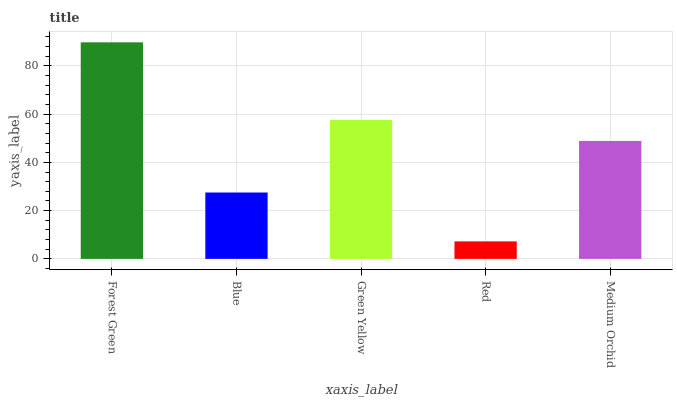Is Red the minimum?
Answer yes or no. Yes. Is Forest Green the maximum?
Answer yes or no. Yes. Is Blue the minimum?
Answer yes or no. No. Is Blue the maximum?
Answer yes or no. No. Is Forest Green greater than Blue?
Answer yes or no. Yes. Is Blue less than Forest Green?
Answer yes or no. Yes. Is Blue greater than Forest Green?
Answer yes or no. No. Is Forest Green less than Blue?
Answer yes or no. No. Is Medium Orchid the high median?
Answer yes or no. Yes. Is Medium Orchid the low median?
Answer yes or no. Yes. Is Green Yellow the high median?
Answer yes or no. No. Is Blue the low median?
Answer yes or no. No. 